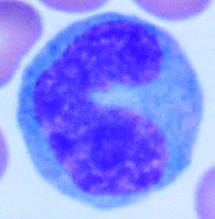when are the majority of tissue macrophages derived from hematopoietic precursors?
Answer the question using a single word or phrase. During inflammatory reactions 